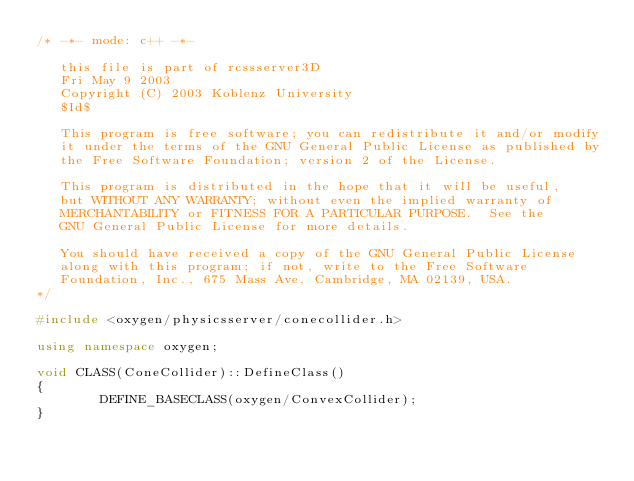Convert code to text. <code><loc_0><loc_0><loc_500><loc_500><_C++_>/* -*- mode: c++ -*-

   this file is part of rcssserver3D
   Fri May 9 2003
   Copyright (C) 2003 Koblenz University
   $Id$

   This program is free software; you can redistribute it and/or modify
   it under the terms of the GNU General Public License as published by
   the Free Software Foundation; version 2 of the License.

   This program is distributed in the hope that it will be useful,
   but WITHOUT ANY WARRANTY; without even the implied warranty of
   MERCHANTABILITY or FITNESS FOR A PARTICULAR PURPOSE.  See the
   GNU General Public License for more details.

   You should have received a copy of the GNU General Public License
   along with this program; if not, write to the Free Software
   Foundation, Inc., 675 Mass Ave, Cambridge, MA 02139, USA.
*/

#include <oxygen/physicsserver/conecollider.h>

using namespace oxygen;

void CLASS(ConeCollider)::DefineClass()
{
        DEFINE_BASECLASS(oxygen/ConvexCollider);
}
</code> 